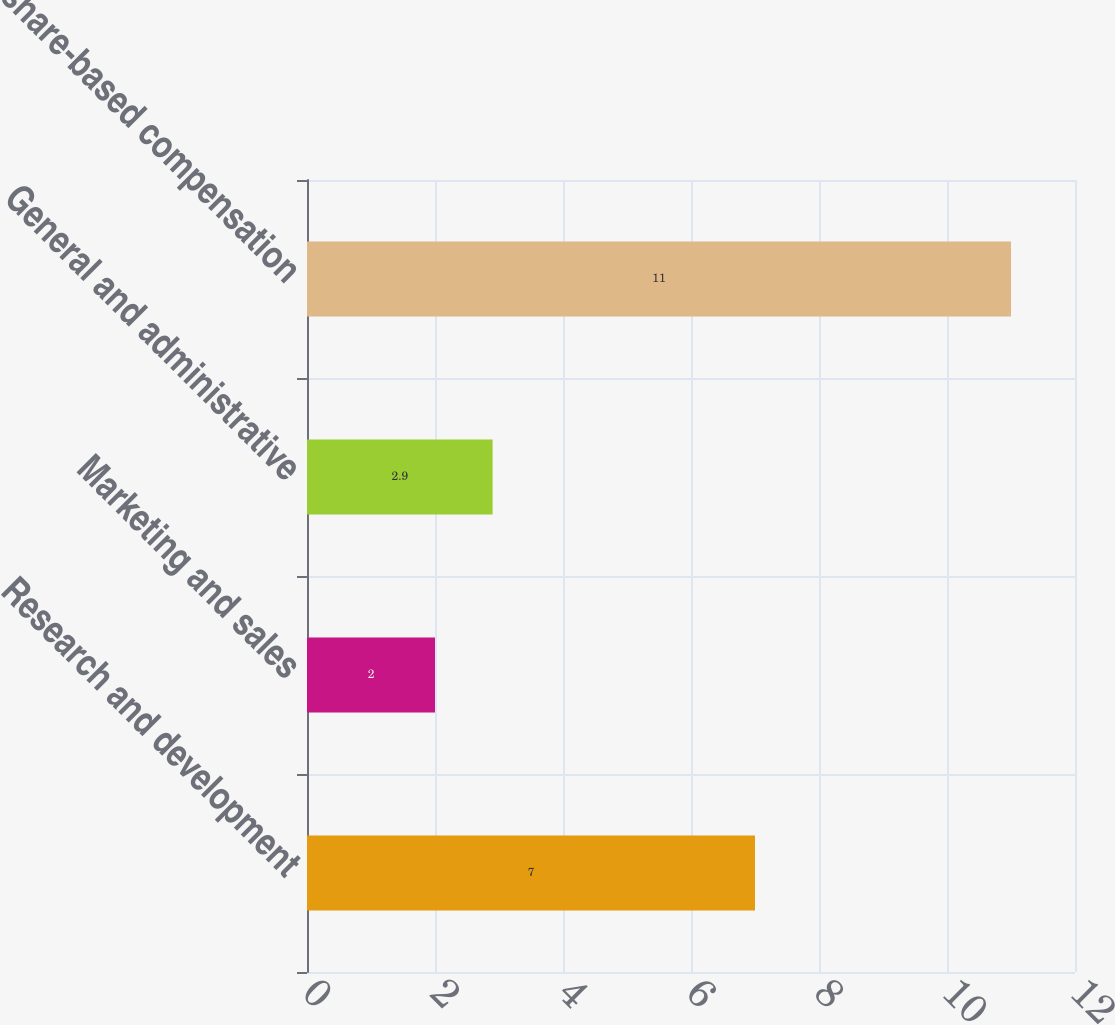Convert chart. <chart><loc_0><loc_0><loc_500><loc_500><bar_chart><fcel>Research and development<fcel>Marketing and sales<fcel>General and administrative<fcel>Total share-based compensation<nl><fcel>7<fcel>2<fcel>2.9<fcel>11<nl></chart> 